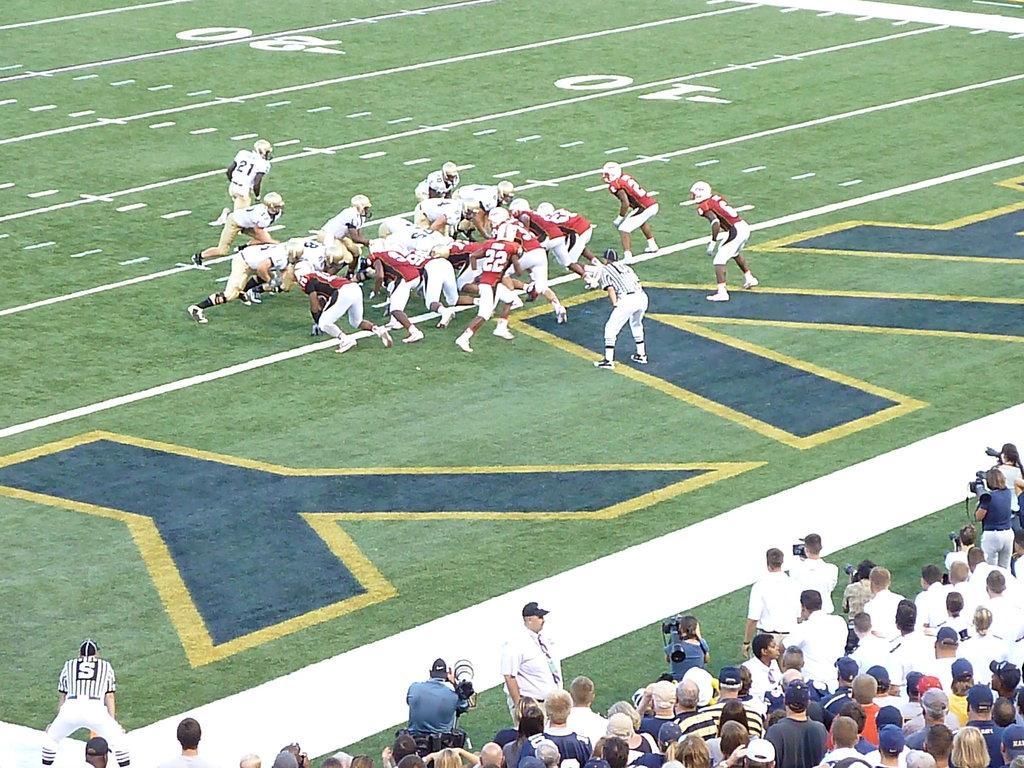Please provide a concise description of this image. In this image there are group of people at the right bottom of the image. Few people are standing and few persons are holding camera. At the middle of image there are group of people are playing game on a grassy land. 